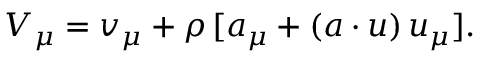Convert formula to latex. <formula><loc_0><loc_0><loc_500><loc_500>V _ { \mu } = v _ { \mu } + \rho \, [ a _ { \mu } + ( a \cdot u ) \, u _ { \mu } ] .</formula> 